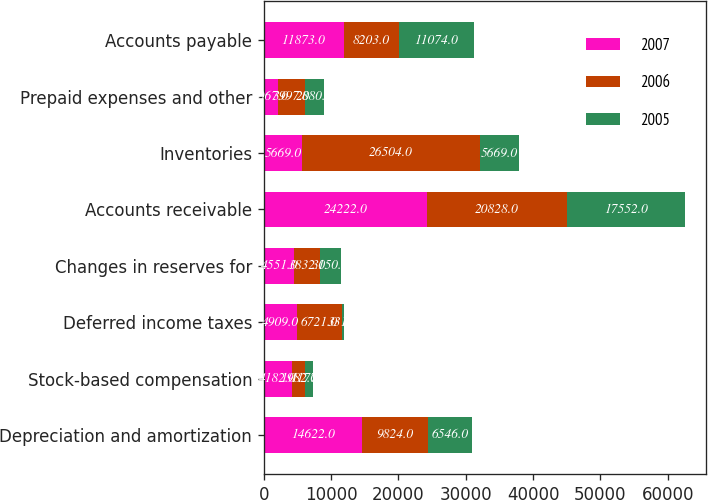Convert chart. <chart><loc_0><loc_0><loc_500><loc_500><stacked_bar_chart><ecel><fcel>Depreciation and amortization<fcel>Stock-based compensation<fcel>Deferred income taxes<fcel>Changes in reserves for<fcel>Accounts receivable<fcel>Inventories<fcel>Prepaid expenses and other<fcel>Accounts payable<nl><fcel>2007<fcel>14622<fcel>4182<fcel>4909<fcel>4551<fcel>24222<fcel>5669<fcel>2067<fcel>11873<nl><fcel>2006<fcel>9824<fcel>1982<fcel>6721<fcel>3832<fcel>20828<fcel>26504<fcel>3997<fcel>8203<nl><fcel>2005<fcel>6546<fcel>1177<fcel>331<fcel>3150<fcel>17552<fcel>5669<fcel>2880<fcel>11074<nl></chart> 